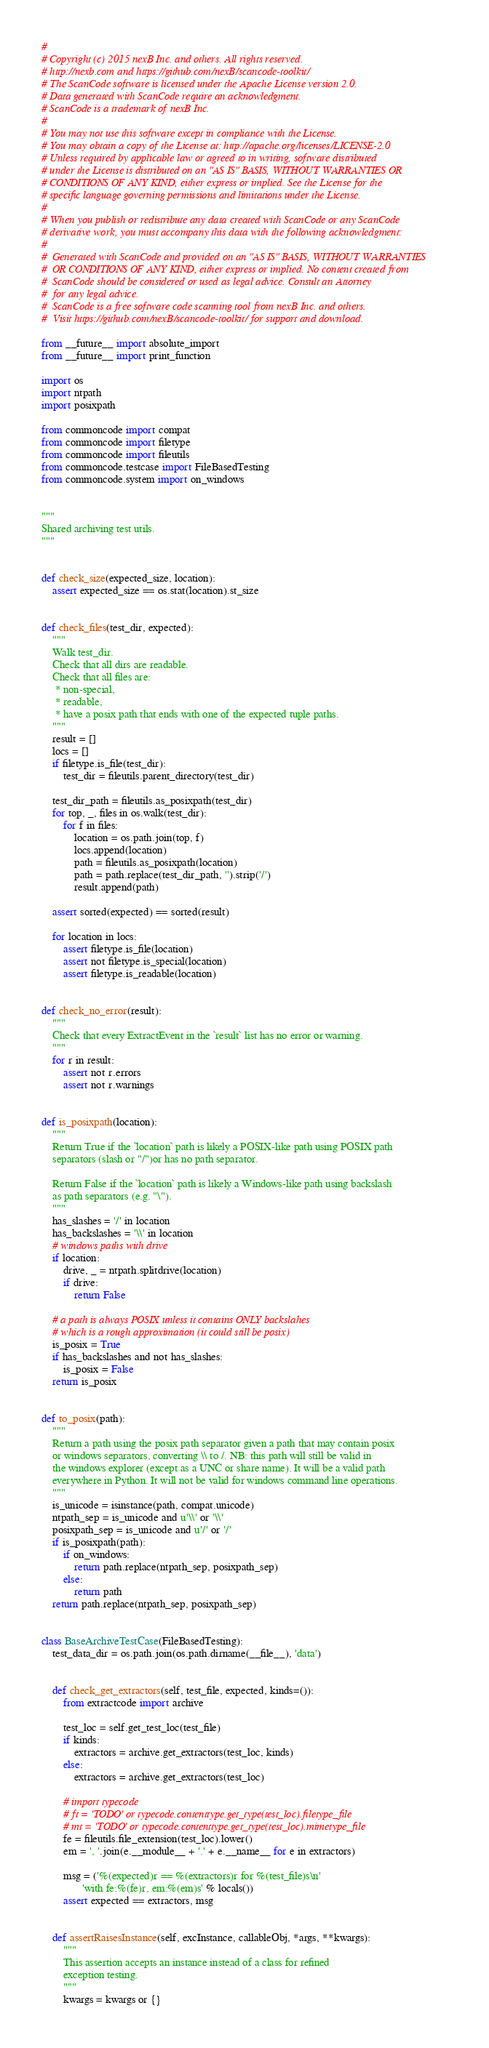Convert code to text. <code><loc_0><loc_0><loc_500><loc_500><_Python_>#
# Copyright (c) 2015 nexB Inc. and others. All rights reserved.
# http://nexb.com and https://github.com/nexB/scancode-toolkit/
# The ScanCode software is licensed under the Apache License version 2.0.
# Data generated with ScanCode require an acknowledgment.
# ScanCode is a trademark of nexB Inc.
#
# You may not use this software except in compliance with the License.
# You may obtain a copy of the License at: http://apache.org/licenses/LICENSE-2.0
# Unless required by applicable law or agreed to in writing, software distributed
# under the License is distributed on an "AS IS" BASIS, WITHOUT WARRANTIES OR
# CONDITIONS OF ANY KIND, either express or implied. See the License for the
# specific language governing permissions and limitations under the License.
#
# When you publish or redistribute any data created with ScanCode or any ScanCode
# derivative work, you must accompany this data with the following acknowledgment:
#
#  Generated with ScanCode and provided on an "AS IS" BASIS, WITHOUT WARRANTIES
#  OR CONDITIONS OF ANY KIND, either express or implied. No content created from
#  ScanCode should be considered or used as legal advice. Consult an Attorney
#  for any legal advice.
#  ScanCode is a free software code scanning tool from nexB Inc. and others.
#  Visit https://github.com/nexB/scancode-toolkit/ for support and download.

from __future__ import absolute_import
from __future__ import print_function

import os
import ntpath
import posixpath

from commoncode import compat
from commoncode import filetype
from commoncode import fileutils
from commoncode.testcase import FileBasedTesting
from commoncode.system import on_windows


"""
Shared archiving test utils.
"""


def check_size(expected_size, location):
    assert expected_size == os.stat(location).st_size


def check_files(test_dir, expected):
    """
    Walk test_dir.
    Check that all dirs are readable.
    Check that all files are:
     * non-special,
     * readable,
     * have a posix path that ends with one of the expected tuple paths.
    """
    result = []
    locs = []
    if filetype.is_file(test_dir):
        test_dir = fileutils.parent_directory(test_dir)

    test_dir_path = fileutils.as_posixpath(test_dir)
    for top, _, files in os.walk(test_dir):
        for f in files:
            location = os.path.join(top, f)
            locs.append(location)
            path = fileutils.as_posixpath(location)
            path = path.replace(test_dir_path, '').strip('/')
            result.append(path)

    assert sorted(expected) == sorted(result)

    for location in locs:
        assert filetype.is_file(location)
        assert not filetype.is_special(location)
        assert filetype.is_readable(location)


def check_no_error(result):
    """
    Check that every ExtractEvent in the `result` list has no error or warning.
    """
    for r in result:
        assert not r.errors
        assert not r.warnings


def is_posixpath(location):
    """
    Return True if the `location` path is likely a POSIX-like path using POSIX path
    separators (slash or "/")or has no path separator.

    Return False if the `location` path is likely a Windows-like path using backslash
    as path separators (e.g. "\").
    """
    has_slashes = '/' in location
    has_backslashes = '\\' in location
    # windows paths with drive
    if location:
        drive, _ = ntpath.splitdrive(location)
        if drive:
            return False

    # a path is always POSIX unless it contains ONLY backslahes
    # which is a rough approximation (it could still be posix)
    is_posix = True
    if has_backslashes and not has_slashes:
        is_posix = False
    return is_posix


def to_posix(path):
    """
    Return a path using the posix path separator given a path that may contain posix
    or windows separators, converting \\ to /. NB: this path will still be valid in
    the windows explorer (except as a UNC or share name). It will be a valid path
    everywhere in Python. It will not be valid for windows command line operations.
    """
    is_unicode = isinstance(path, compat.unicode)
    ntpath_sep = is_unicode and u'\\' or '\\'
    posixpath_sep = is_unicode and u'/' or '/'
    if is_posixpath(path):
        if on_windows:
            return path.replace(ntpath_sep, posixpath_sep)
        else:
            return path
    return path.replace(ntpath_sep, posixpath_sep)


class BaseArchiveTestCase(FileBasedTesting):
    test_data_dir = os.path.join(os.path.dirname(__file__), 'data')


    def check_get_extractors(self, test_file, expected, kinds=()):
        from extractcode import archive

        test_loc = self.get_test_loc(test_file)
        if kinds:
            extractors = archive.get_extractors(test_loc, kinds)
        else:
            extractors = archive.get_extractors(test_loc)

        # import typecode
        # ft = 'TODO' or typecode.contenttype.get_type(test_loc).filetype_file
        # mt = 'TODO' or typecode.contenttype.get_type(test_loc).mimetype_file
        fe = fileutils.file_extension(test_loc).lower()
        em = ', '.join(e.__module__ + '.' + e.__name__ for e in extractors)

        msg = ('%(expected)r == %(extractors)r for %(test_file)s\n'
               'with fe:%(fe)r, em:%(em)s' % locals())
        assert expected == extractors, msg


    def assertRaisesInstance(self, excInstance, callableObj, *args, **kwargs):
        """
        This assertion accepts an instance instead of a class for refined
        exception testing.
        """
        kwargs = kwargs or {}</code> 